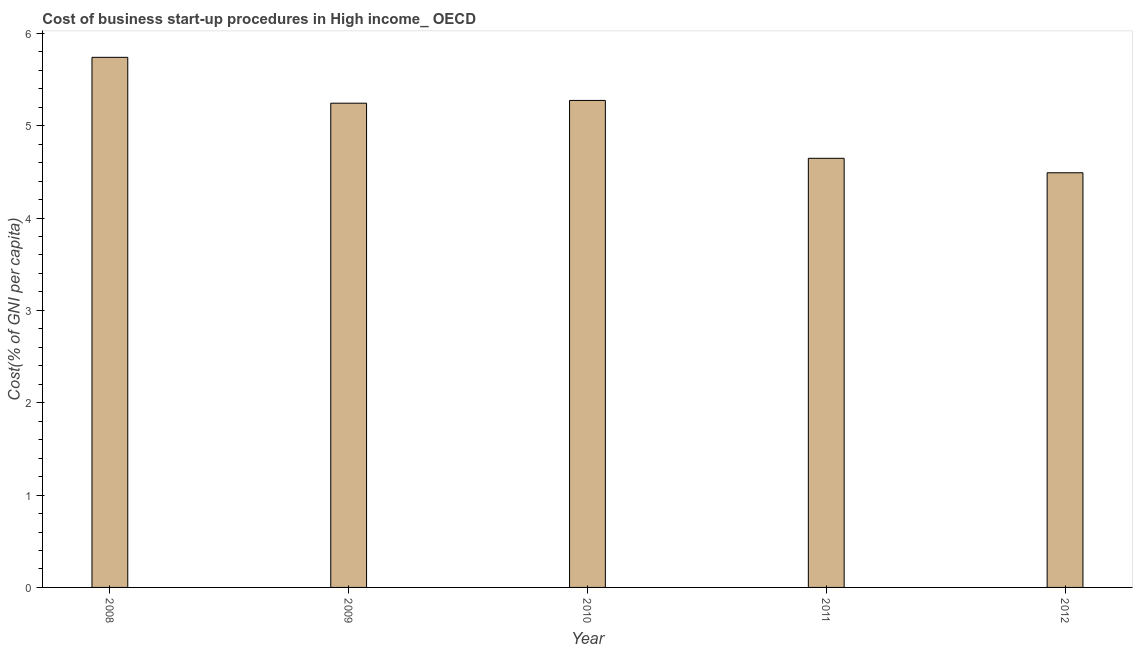Does the graph contain grids?
Your answer should be very brief. No. What is the title of the graph?
Keep it short and to the point. Cost of business start-up procedures in High income_ OECD. What is the label or title of the X-axis?
Ensure brevity in your answer.  Year. What is the label or title of the Y-axis?
Give a very brief answer. Cost(% of GNI per capita). What is the cost of business startup procedures in 2009?
Offer a terse response. 5.24. Across all years, what is the maximum cost of business startup procedures?
Give a very brief answer. 5.74. Across all years, what is the minimum cost of business startup procedures?
Your answer should be compact. 4.49. What is the sum of the cost of business startup procedures?
Ensure brevity in your answer.  25.39. What is the difference between the cost of business startup procedures in 2008 and 2009?
Provide a short and direct response. 0.5. What is the average cost of business startup procedures per year?
Keep it short and to the point. 5.08. What is the median cost of business startup procedures?
Ensure brevity in your answer.  5.24. Do a majority of the years between 2010 and 2012 (inclusive) have cost of business startup procedures greater than 3.2 %?
Your response must be concise. Yes. What is the ratio of the cost of business startup procedures in 2008 to that in 2012?
Offer a terse response. 1.28. Is the difference between the cost of business startup procedures in 2011 and 2012 greater than the difference between any two years?
Offer a very short reply. No. What is the difference between the highest and the second highest cost of business startup procedures?
Keep it short and to the point. 0.47. Is the sum of the cost of business startup procedures in 2008 and 2011 greater than the maximum cost of business startup procedures across all years?
Keep it short and to the point. Yes. In how many years, is the cost of business startup procedures greater than the average cost of business startup procedures taken over all years?
Keep it short and to the point. 3. How many bars are there?
Keep it short and to the point. 5. Are the values on the major ticks of Y-axis written in scientific E-notation?
Your response must be concise. No. What is the Cost(% of GNI per capita) in 2008?
Give a very brief answer. 5.74. What is the Cost(% of GNI per capita) in 2009?
Give a very brief answer. 5.24. What is the Cost(% of GNI per capita) of 2010?
Make the answer very short. 5.27. What is the Cost(% of GNI per capita) in 2011?
Provide a succinct answer. 4.65. What is the Cost(% of GNI per capita) in 2012?
Give a very brief answer. 4.49. What is the difference between the Cost(% of GNI per capita) in 2008 and 2009?
Offer a terse response. 0.5. What is the difference between the Cost(% of GNI per capita) in 2008 and 2010?
Provide a short and direct response. 0.47. What is the difference between the Cost(% of GNI per capita) in 2008 and 2011?
Give a very brief answer. 1.09. What is the difference between the Cost(% of GNI per capita) in 2009 and 2010?
Offer a very short reply. -0.03. What is the difference between the Cost(% of GNI per capita) in 2009 and 2011?
Your answer should be very brief. 0.6. What is the difference between the Cost(% of GNI per capita) in 2009 and 2012?
Your answer should be very brief. 0.75. What is the difference between the Cost(% of GNI per capita) in 2010 and 2011?
Give a very brief answer. 0.63. What is the difference between the Cost(% of GNI per capita) in 2010 and 2012?
Ensure brevity in your answer.  0.78. What is the difference between the Cost(% of GNI per capita) in 2011 and 2012?
Your answer should be compact. 0.16. What is the ratio of the Cost(% of GNI per capita) in 2008 to that in 2009?
Give a very brief answer. 1.09. What is the ratio of the Cost(% of GNI per capita) in 2008 to that in 2010?
Make the answer very short. 1.09. What is the ratio of the Cost(% of GNI per capita) in 2008 to that in 2011?
Offer a very short reply. 1.24. What is the ratio of the Cost(% of GNI per capita) in 2008 to that in 2012?
Make the answer very short. 1.28. What is the ratio of the Cost(% of GNI per capita) in 2009 to that in 2010?
Ensure brevity in your answer.  0.99. What is the ratio of the Cost(% of GNI per capita) in 2009 to that in 2011?
Provide a short and direct response. 1.13. What is the ratio of the Cost(% of GNI per capita) in 2009 to that in 2012?
Provide a succinct answer. 1.17. What is the ratio of the Cost(% of GNI per capita) in 2010 to that in 2011?
Provide a succinct answer. 1.14. What is the ratio of the Cost(% of GNI per capita) in 2010 to that in 2012?
Make the answer very short. 1.17. What is the ratio of the Cost(% of GNI per capita) in 2011 to that in 2012?
Offer a terse response. 1.03. 